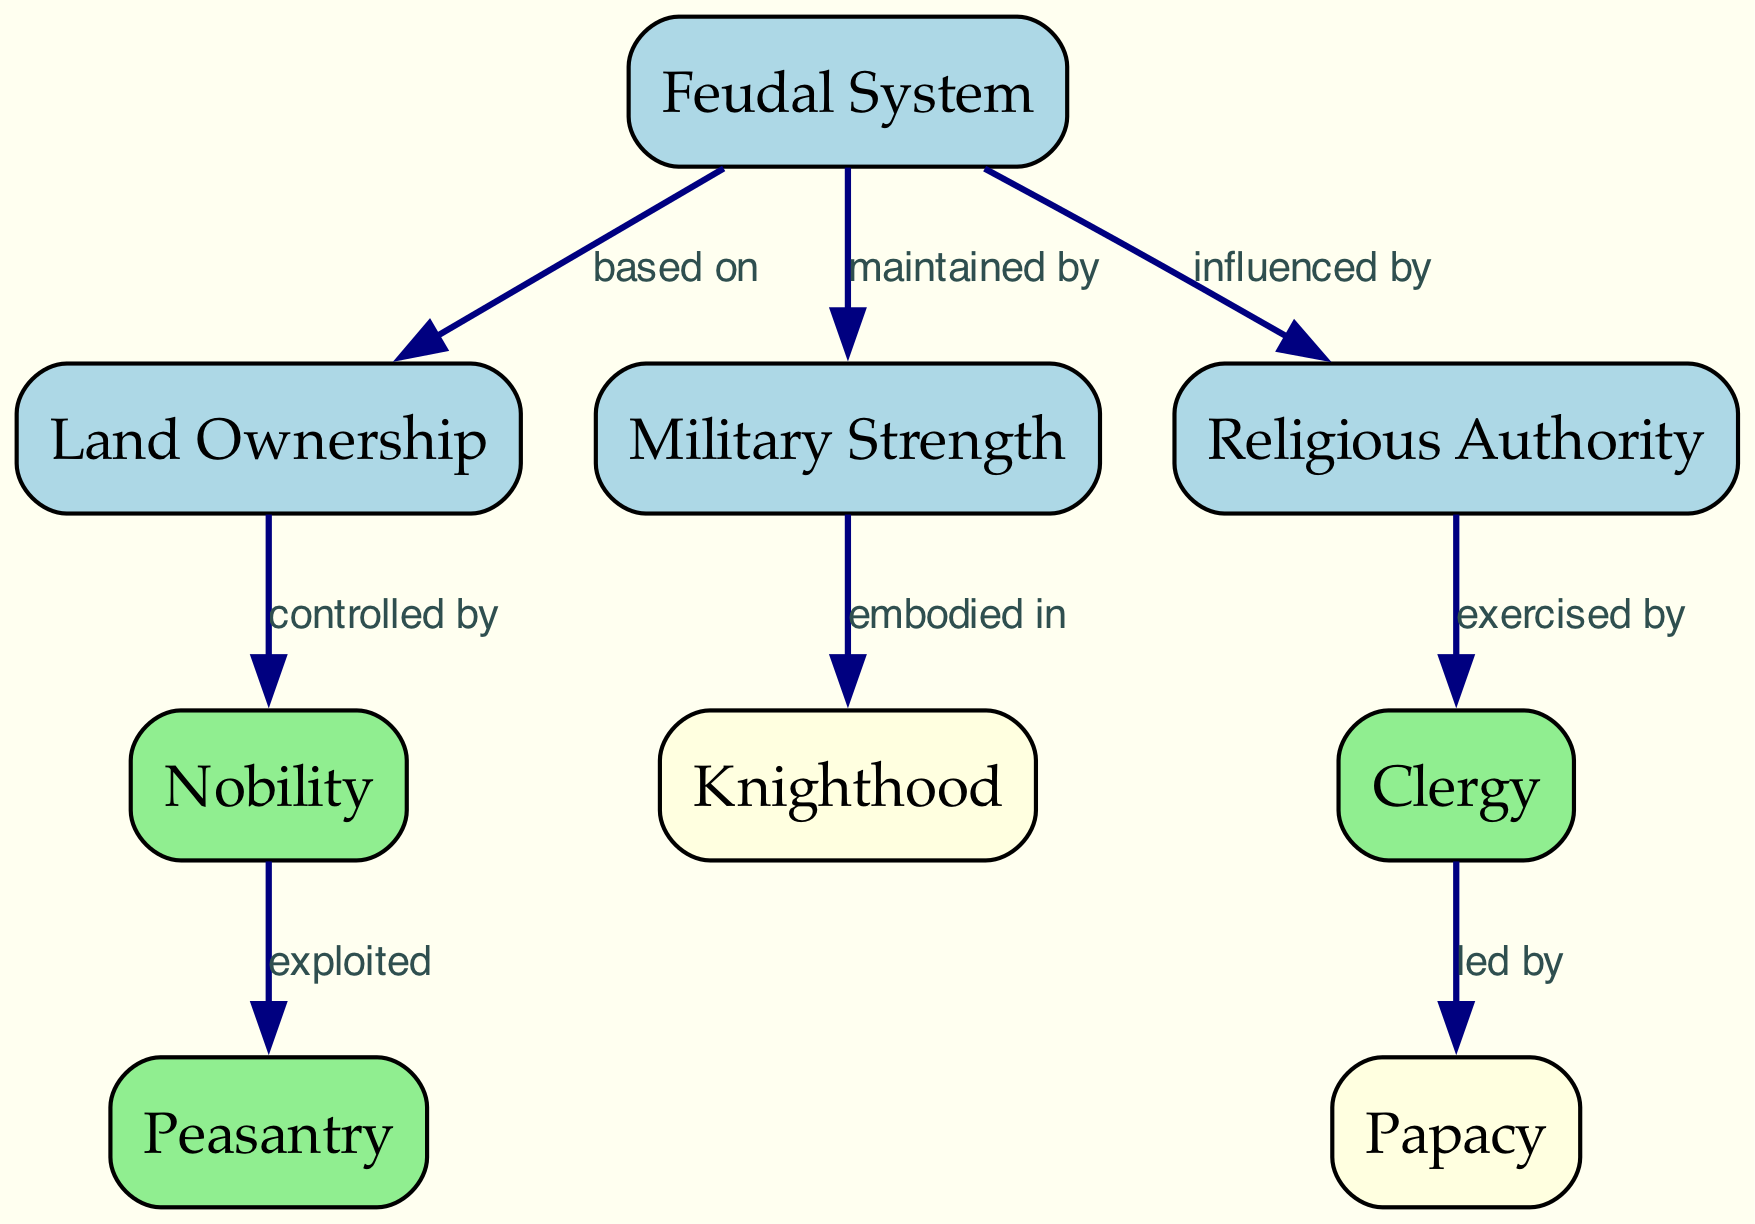What is the main basis of the feudal system? The diagram indicates that the feudal system is fundamentally based on land ownership, as illustrated by the directed edge labeled "based on" connecting "Feudal System" to "Land Ownership."
Answer: Land Ownership Which group controls land ownership? According to the diagram, the edge labeled "controlled by" shows that nobility has control over land ownership, connecting "Land Ownership" to "Nobility."
Answer: Nobility What is military strength embodied in? The diagram indicates that military strength is embodied in the knighthood, as depicted by the edge labeled "embodied in" linking "Military Strength" to "Knighthood."
Answer: Knighthood How does religious authority influence the feudal system? The diagram shows a directed edge from "Feudal System" to "Religious Authority," labeled "influenced by," indicating that the feudal system is affected by religious authority.
Answer: Influenced by How many nodes are there in the diagram? To determine the number of nodes, one counts the distinct entities: feudalism, land ownership, military strength, religious authority, nobility, clergy, peasantry, knighthood, and papacy. There are 9 distinct nodes in total.
Answer: 9 What group is exploited by the nobility? The diagram shows an edge from "Nobility" to "Peasantry," labeled "exploited," which reveals that the peasantry is the group that is exploited by the nobility.
Answer: Peasantry Who leads the clergy? The directed edge labeled "led by" connects "Clergy" to "Papacy," indicating that the clergy is led by the papacy as illustrated in the diagram.
Answer: Papacy What are the three key factors influencing power dynamics in medieval Europe? By reviewing the primary nodes linked to the feudal system—land ownership, military strength, and religious authority—one can identify these as the three critical factors.
Answer: Land Ownership, Military Strength, Religious Authority What is the relationship between military strength and knighthood? The relationship is depicted by the edge labeled "embodied in" from "Military Strength" to "Knighthood," which indicates that military strength is represented through knighthood.
Answer: Embodied in 